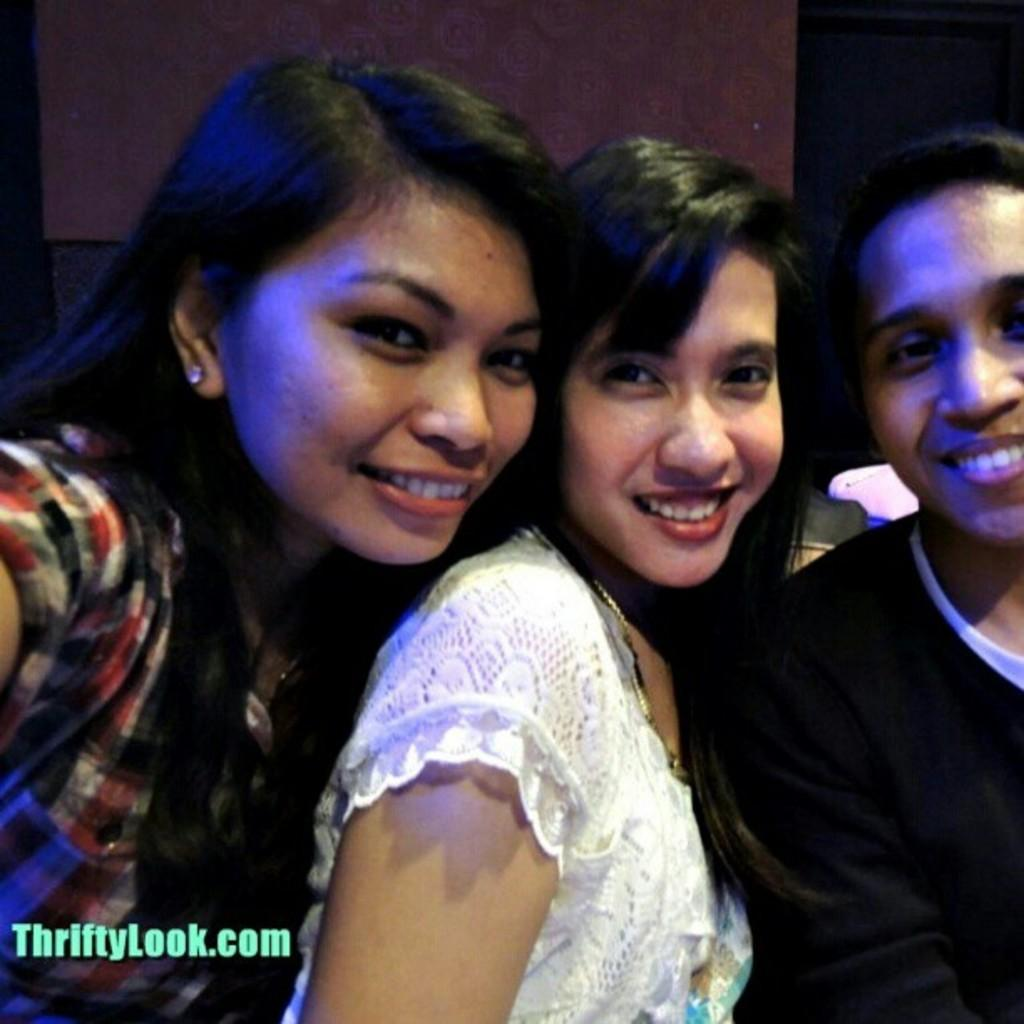How many people are in the front of the image? There are three people standing in the front of the image. Can you describe the woman in the middle? The woman in the middle is wearing a white dress. What can be seen behind the people in the image? There is a wall visible behind the people. What type of jar is the woman holding in the image? There is no jar present in the image; the woman is not holding anything. 